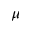Convert formula to latex. <formula><loc_0><loc_0><loc_500><loc_500>\mu</formula> 